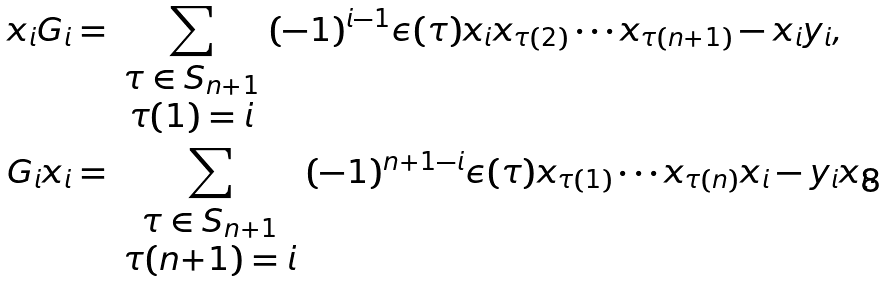<formula> <loc_0><loc_0><loc_500><loc_500>x _ { i } G _ { i } & = \sum _ { \begin{array} { c } \tau \in S _ { n + 1 } \\ \tau ( 1 ) = i \end{array} } ( - 1 ) ^ { i - 1 } \epsilon ( \tau ) x _ { i } x _ { \tau ( 2 ) } \cdots x _ { \tau ( n + 1 ) } - x _ { i } y _ { i } , \\ G _ { i } x _ { i } & = \sum _ { \begin{array} { c } \tau \in S _ { n + 1 } \\ \tau ( n { + } 1 ) = i \end{array} } ( - 1 ) ^ { n + 1 - i } \epsilon ( \tau ) x _ { \tau ( 1 ) } \cdots x _ { \tau ( n ) } x _ { i } - y _ { i } x _ { i } .</formula> 